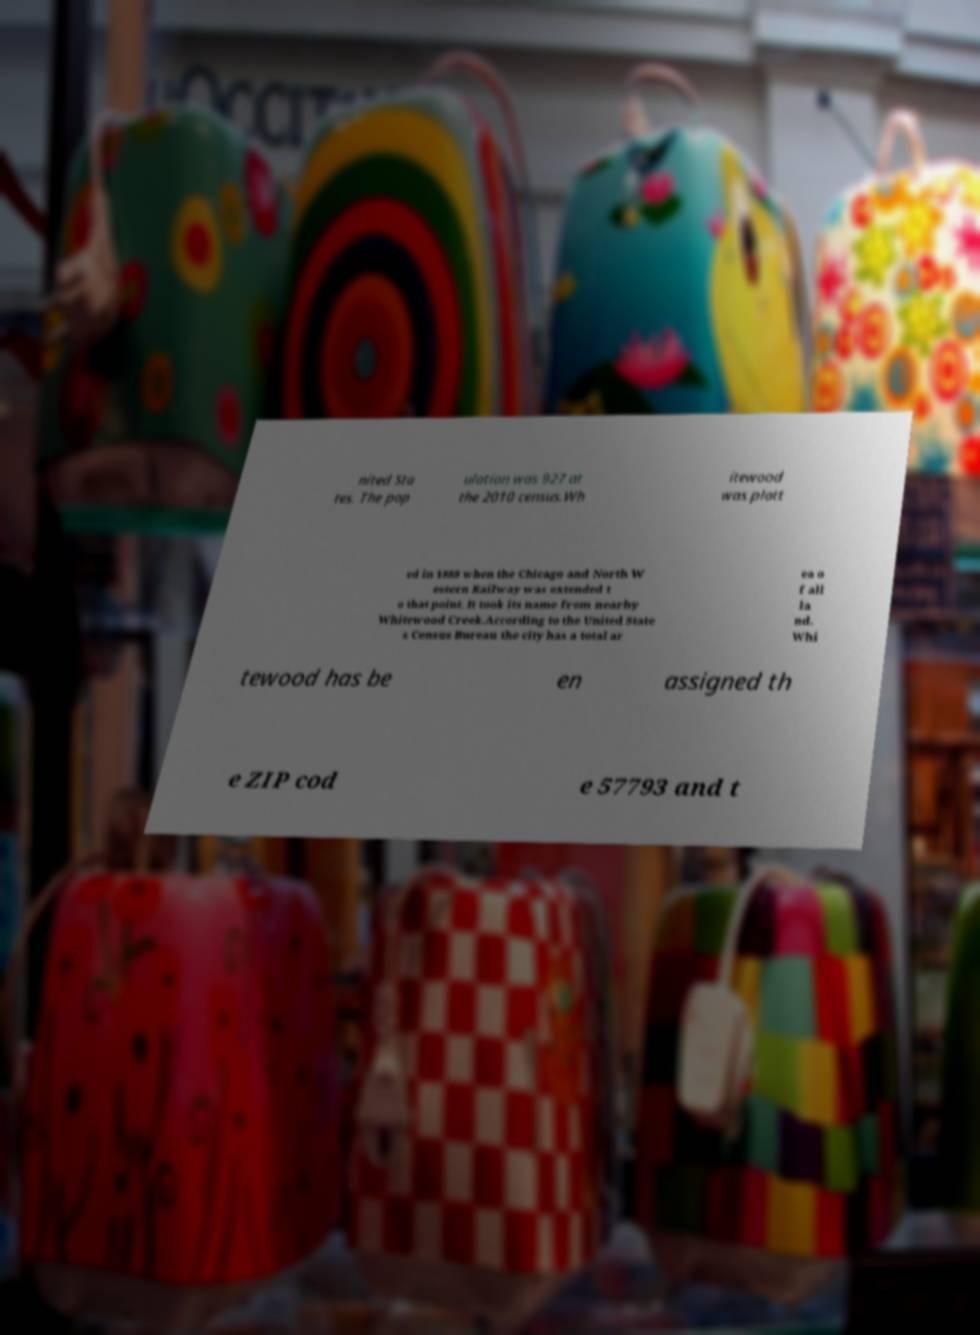Could you assist in decoding the text presented in this image and type it out clearly? nited Sta tes. The pop ulation was 927 at the 2010 census.Wh itewood was platt ed in 1888 when the Chicago and North W estern Railway was extended t o that point. It took its name from nearby Whitewood Creek.According to the United State s Census Bureau the city has a total ar ea o f all la nd. Whi tewood has be en assigned th e ZIP cod e 57793 and t 